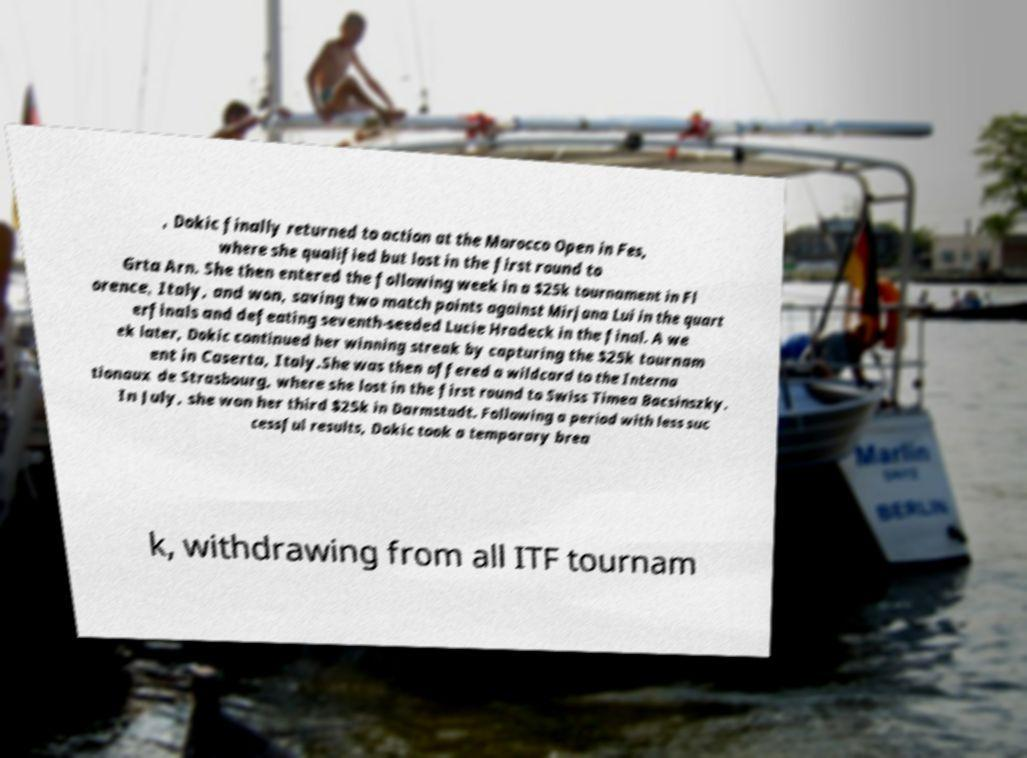What messages or text are displayed in this image? I need them in a readable, typed format. , Dokic finally returned to action at the Morocco Open in Fes, where she qualified but lost in the first round to Grta Arn. She then entered the following week in a $25k tournament in Fl orence, Italy, and won, saving two match points against Mirjana Lui in the quart erfinals and defeating seventh-seeded Lucie Hradeck in the final. A we ek later, Dokic continued her winning streak by capturing the $25k tournam ent in Caserta, Italy.She was then offered a wildcard to the Interna tionaux de Strasbourg, where she lost in the first round to Swiss Timea Bacsinszky. In July, she won her third $25k in Darmstadt. Following a period with less suc cessful results, Dokic took a temporary brea k, withdrawing from all ITF tournam 